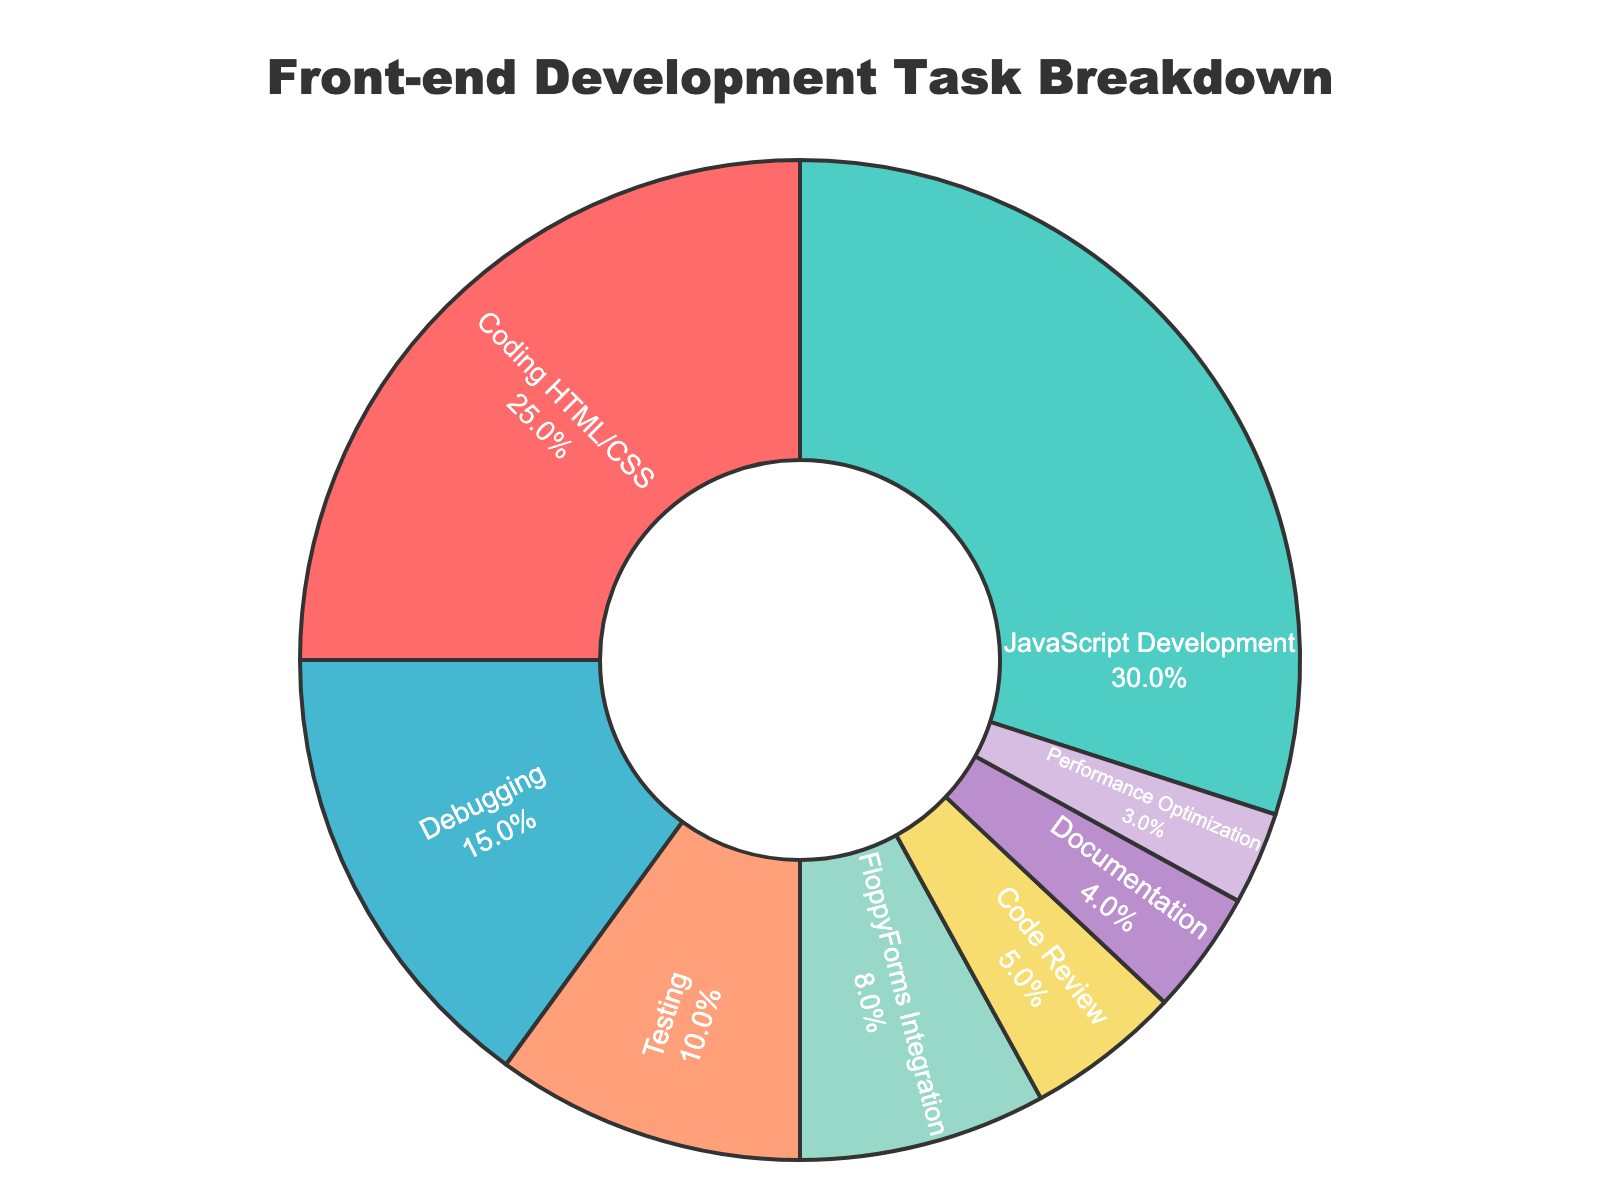Which task has the highest percentage of time spent? To find the task with the highest percentage, look at the data and identify the category with the largest value. JavaScript Development has 30%, which is the largest percentage.
Answer: JavaScript Development Which task has the least percentage of time spent? To determine the task with the least percentage, note the category with the smallest value in the data. Performance Optimization has 3%, which is the smallest percentage.
Answer: Performance Optimization What is the combined percentage of time spent on Debugging and Testing? Add the percentages for Debugging and Testing. Debugging is 15% and Testing is 10%, so the combined percentage is 15% + 10% = 25%.
Answer: 25% Is more time spent on FloppyForms Integration or Documentation? Compare the percentages of FloppyForms Integration and Documentation. FloppyForms Integration is 8% and Documentation is 4%, so more time is spent on FloppyForms Integration.
Answer: FloppyForms Integration What is the percentage difference between Code Review and Performance Optimization? Subtract the percentage of Performance Optimization from the percentage of Code Review. Code Review is 5% and Performance Optimization is 3%, so the difference is 5% - 3% = 2%.
Answer: 2% What percentage of tasks other than Coding HTML/CSS and JavaScript Development is accounted for? Add the percentages for all tasks except Coding HTML/CSS and JavaScript Development (sum all the other percentages). 15% (Debugging) + 10% (Testing) + 8% (FloppyForms Integration) + 5% (Code Review) + 4% (Documentation) + 3% (Performance Optimization) = 45%.
Answer: 45% How does the percentage of time spent Coding HTML/CSS compare to the combined percentage of Documentation and Code Review? Calculate the combined percentage of Documentation and Code Review, then compare it to the percentage of Coding HTML/CSS. Documentation is 4% and Code Review is 5%, which combined is 9%. Coding HTML/CSS is 25%. So, 25% is greater than 9%.
Answer: Coding HTML/CSS is greater What is the average percentage of time spent across all tasks? Sum all the percentages and divide by the number of tasks. (25% + 30% + 15% + 10% + 8% + 5% + 4% + 3%) / 8 = 100% / 8 = 12.5%.
Answer: 12.5% Which tasks take up more than 20% of the time each? Identify the tasks with percentages greater than 20%. Coding HTML/CSS is 25% and JavaScript Development is 30%.
Answer: Coding HTML/CSS, JavaScript Development 